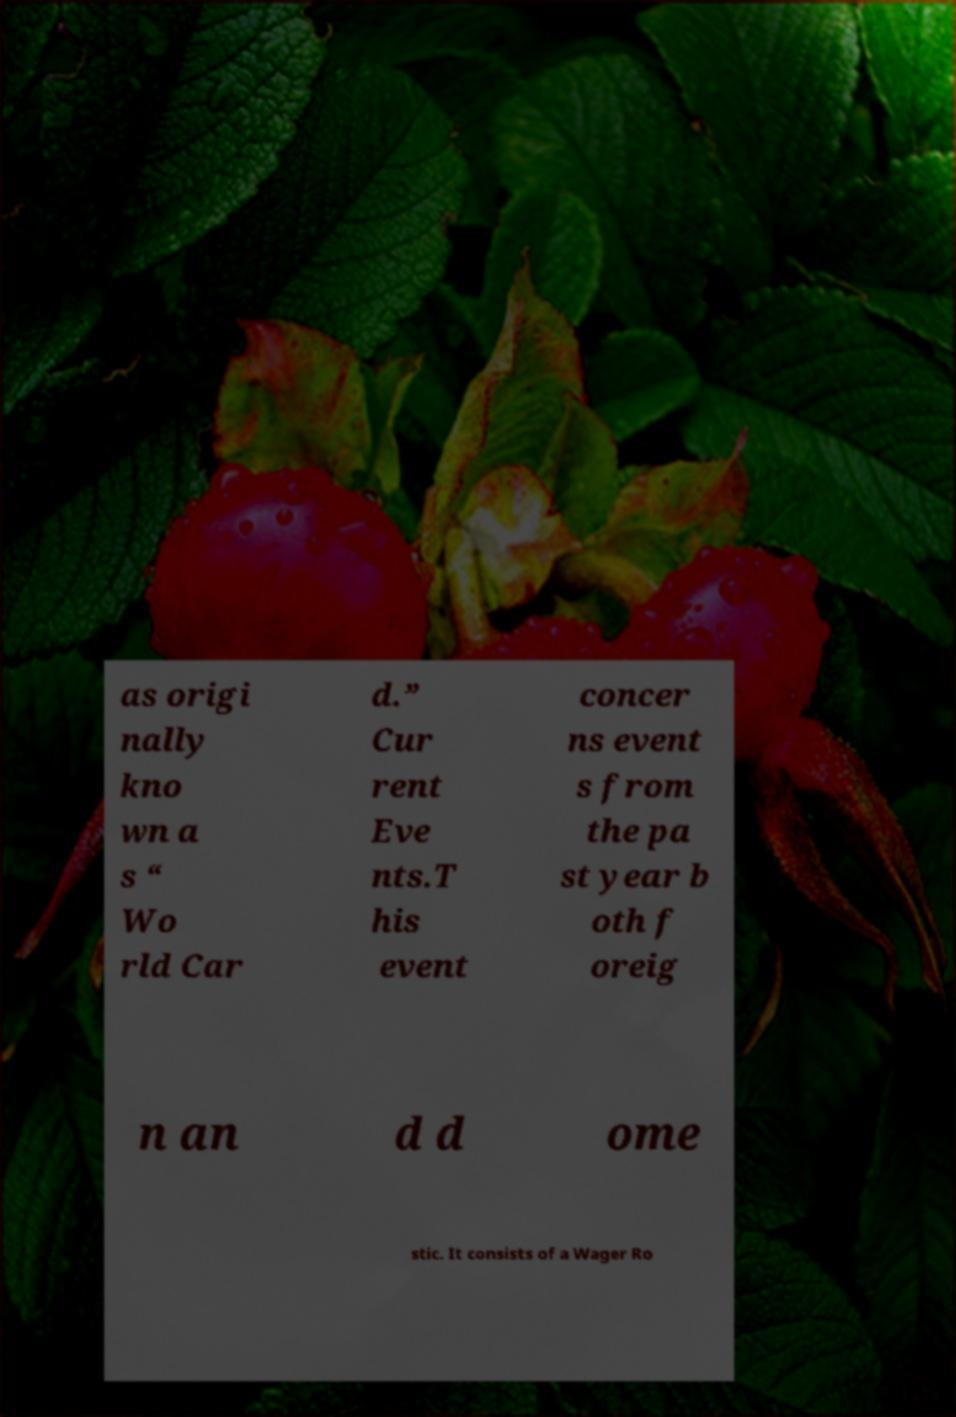Can you accurately transcribe the text from the provided image for me? as origi nally kno wn a s “ Wo rld Car d.” Cur rent Eve nts.T his event concer ns event s from the pa st year b oth f oreig n an d d ome stic. It consists of a Wager Ro 